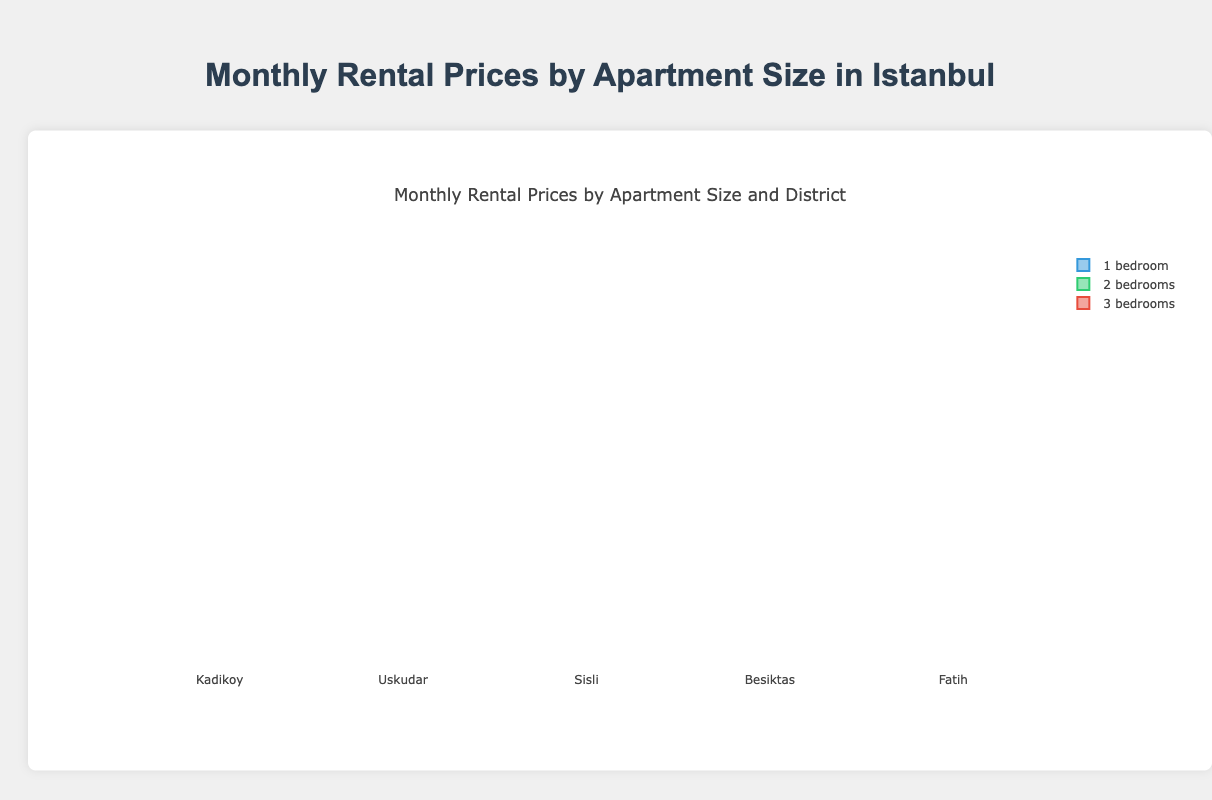What is the highest median rental price for 1-bedroom apartments across the districts? The median is the middle value when the data points are sorted. For 1-bedroom apartments, the medians across the districts are [3600, 3300, 4100, 4600, 2900]. The highest is 4600 in Besiktas.
Answer: 4600 Which district has the lowest median rental price for 2-bedroom apartments? The medians for the 2-bedroom apartments in each district are [4600, 4300, 4900, 5400, 3900]. The lowest is 3900 in Fatih.
Answer: Fatih Between Kadikoy and Besiktas, which one has a higher range of prices for 3-bedroom apartments? The range is the difference between the maximum and the minimum values. For Kadikoy, it's 5700 - 5400 = 300. For Besiktas, it's 6500 - 6200 = 300. Both have the same range of 300.
Answer: Both have the same range Which district shows the highest variation in prices for 1-bedroom apartments? The variation can be approximated by the range for a basic understanding. The ranges are Kadikoy: 3700 - 3400 = 300, Uskudar: 3400 - 3100 = 300, Sisli: 4200 - 3900 = 300, Besiktas: 4700 - 4400 = 300, Fatih: 3000 - 2700 = 300. All have equal range of 300.
Answer: All have equal range Does Sisli have a higher median rental price for 2-bedroom or 3-bedroom apartments? The medians are determined from the sorted data points. For 2-bedroom, Sisli's median is 4900. For 3-bedroom, Sisli's median is 5900.
Answer: 3-bedroom How do the rental prices for 2-bedroom apartments in Uskudar compare to those in Kadikoy? The medians are used for comparison. Uskudar’s median for 2-bedroom is 4300 and Kadikoy’s median for 2-bedroom is 4600. Kadikoy has higher median rental prices.
Answer: Kadikoy In which district is the box plot for 3-bedroom apartments the shortest? The shortest box plot indicates the smallest interquartile range (IQR). By looking at the IQRs: Kadikoy (5600-5500=100), Uskudar (5300-5200=100), Sisli (5900-5800=100), Besiktas (6400-6300=100), Fatih (4900-4800=100). All have the same length.
Answer: All have the same length What is the interquartile range (IQR) for 2-bedroom apartments in Besiktas? The IQR is the range between the first and third quartiles. From 5200 to 5400 gives an IQR of 5400 - 5200 = 200.
Answer: 200 